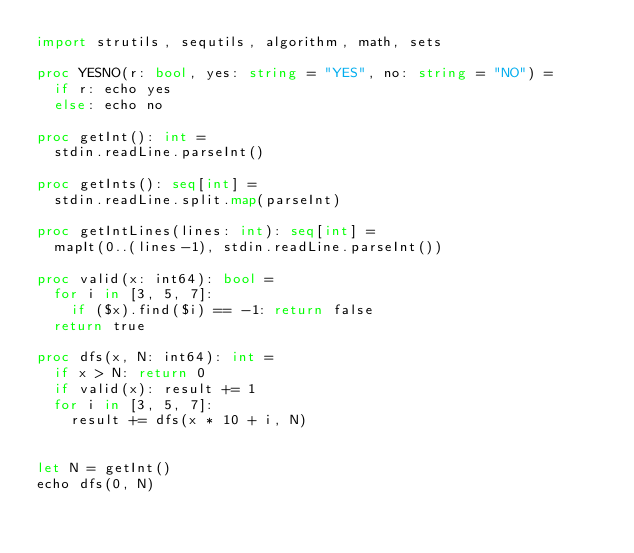Convert code to text. <code><loc_0><loc_0><loc_500><loc_500><_Nim_>import strutils, sequtils, algorithm, math, sets

proc YESNO(r: bool, yes: string = "YES", no: string = "NO") =
  if r: echo yes
  else: echo no

proc getInt(): int =
  stdin.readLine.parseInt()

proc getInts(): seq[int] =
  stdin.readLine.split.map(parseInt)

proc getIntLines(lines: int): seq[int] =
  mapIt(0..(lines-1), stdin.readLine.parseInt())

proc valid(x: int64): bool =
  for i in [3, 5, 7]:
    if ($x).find($i) == -1: return false
  return true

proc dfs(x, N: int64): int =
  if x > N: return 0
  if valid(x): result += 1
  for i in [3, 5, 7]:
    result += dfs(x * 10 + i, N)


let N = getInt()
echo dfs(0, N)</code> 